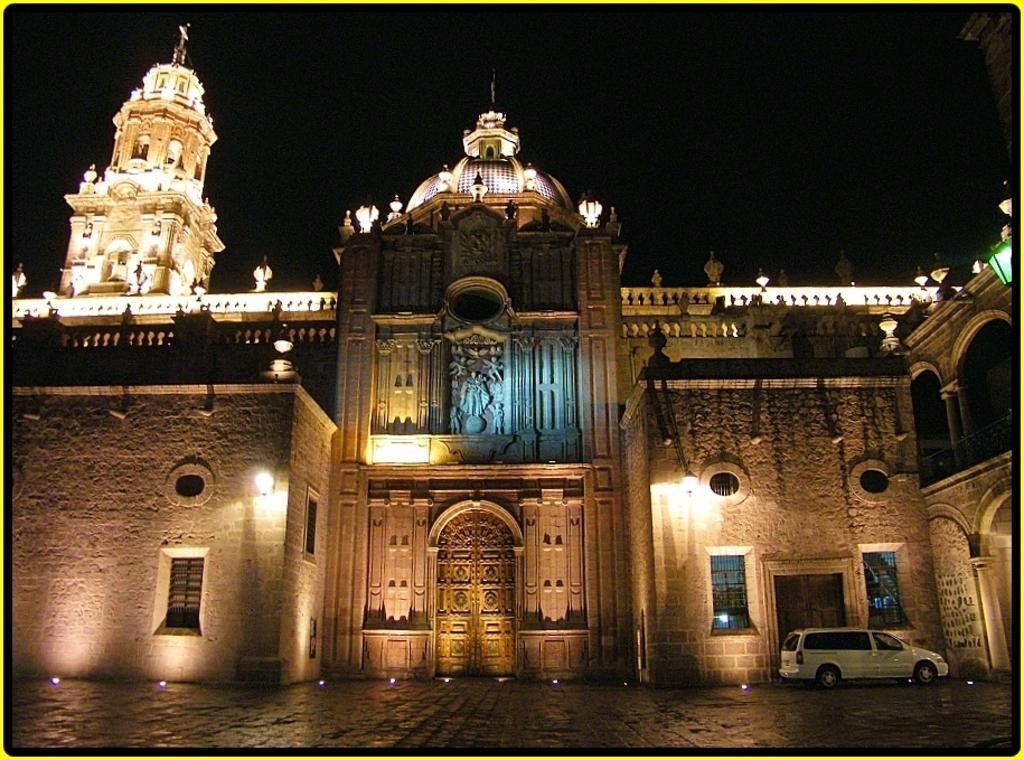Describe this image in one or two sentences. In this image I can see a building. I can also see number of lights on the walls and on the top of this building. On the right side of this image I can see a white colour car. 